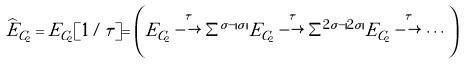Convert formula to latex. <formula><loc_0><loc_0><loc_500><loc_500>\widehat { E } _ { C _ { 2 } } & = E _ { C _ { 2 } } [ 1 / \tau ] = \left ( E _ { C _ { 2 } } \overset { \tau } { \longrightarrow } \Sigma ^ { \sigma - | \sigma | } E _ { C _ { 2 } } \overset { \tau } { \longrightarrow } \Sigma ^ { 2 \sigma - | 2 \sigma | } E _ { C _ { 2 } } \overset { \tau } { \longrightarrow } \cdots \right )</formula> 